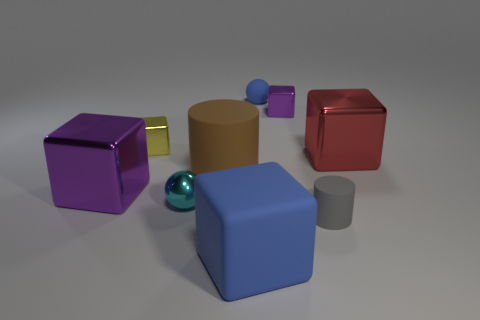Are there any big blue things that are behind the matte cylinder that is in front of the large metal block left of the large red object?
Ensure brevity in your answer.  No. How many small objects are rubber balls or purple cubes?
Give a very brief answer. 2. There is a rubber object that is the same size as the brown cylinder; what is its color?
Your answer should be compact. Blue. There is a blue sphere; what number of red things are on the left side of it?
Your answer should be compact. 0. Are there any cylinders made of the same material as the small yellow thing?
Offer a terse response. No. There is a small object that is the same color as the rubber block; what shape is it?
Keep it short and to the point. Sphere. The cylinder behind the large purple block is what color?
Provide a short and direct response. Brown. Are there the same number of gray rubber things that are right of the big blue object and rubber balls that are to the left of the tiny blue matte ball?
Offer a terse response. No. The blue thing that is in front of the purple metal object to the left of the large matte cylinder is made of what material?
Offer a very short reply. Rubber. How many things are either big green cylinders or gray cylinders right of the small blue rubber thing?
Ensure brevity in your answer.  1. 